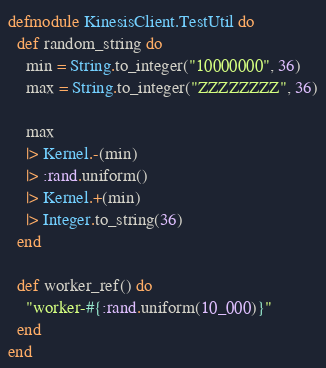<code> <loc_0><loc_0><loc_500><loc_500><_Elixir_>defmodule KinesisClient.TestUtil do
  def random_string do
    min = String.to_integer("10000000", 36)
    max = String.to_integer("ZZZZZZZZ", 36)

    max
    |> Kernel.-(min)
    |> :rand.uniform()
    |> Kernel.+(min)
    |> Integer.to_string(36)
  end

  def worker_ref() do
    "worker-#{:rand.uniform(10_000)}"
  end
end
</code> 